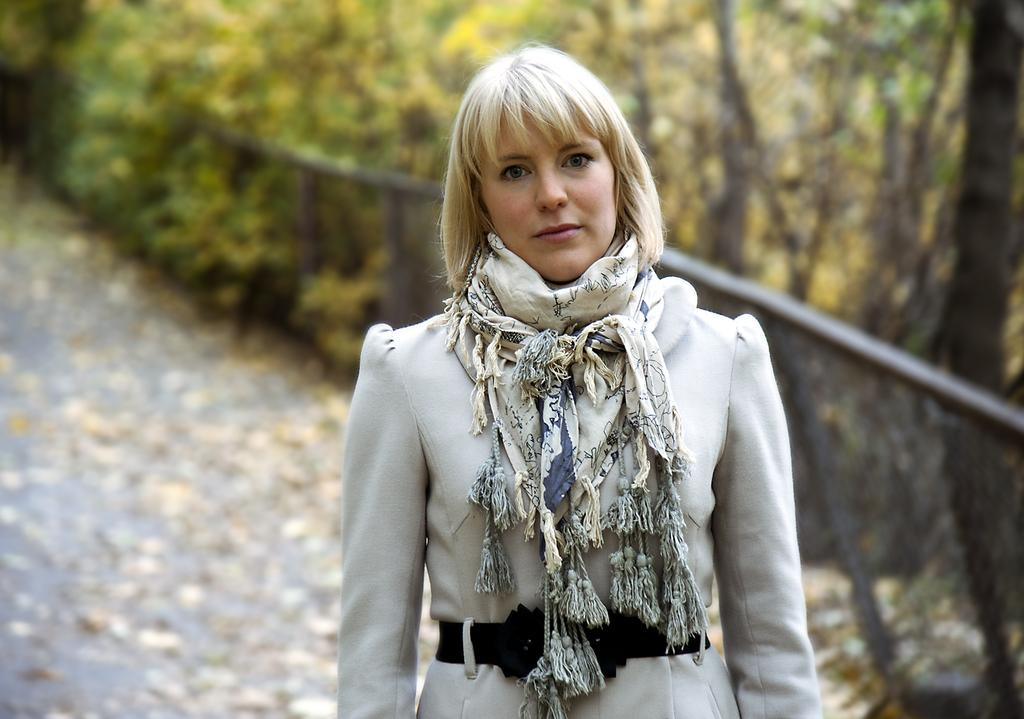Who is present in the image? There is a woman in the image. What is the woman doing in the image? The woman is standing in the image. What is the woman wearing in the image? The woman is wearing a scarf in the image. What type of natural elements can be seen in the image? There are trees in the image. What type of man-made structure is present in the image? There is fencing in the image. What type of coach can be seen in the image? There is no coach present in the image. What is the woman's chin doing in the image? The woman's chin is not doing anything in the image; it is simply part of her facial features. 